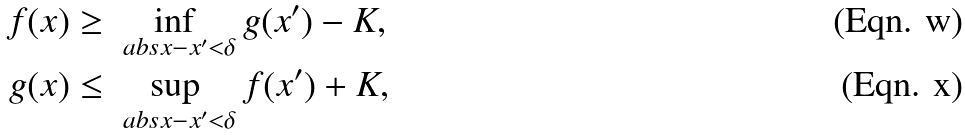<formula> <loc_0><loc_0><loc_500><loc_500>f ( x ) & \geq \inf _ { \ a b s { x - x ^ { \prime } } < \delta } g ( x ^ { \prime } ) - K , \\ g ( x ) & \leq \sup _ { \ a b s { x - x ^ { \prime } } < \delta } f ( x ^ { \prime } ) + K ,</formula> 